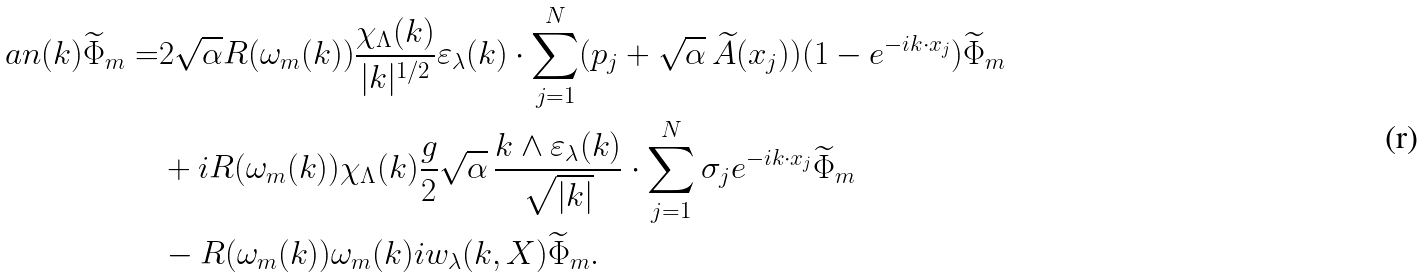<formula> <loc_0><loc_0><loc_500><loc_500>\ a n ( k ) \widetilde { \Phi } _ { m } = & 2 \sqrt { \alpha } R ( \omega _ { m } ( k ) ) \frac { \chi _ { \Lambda } ( k ) } { | k | ^ { 1 / 2 } } \varepsilon _ { \lambda } ( k ) \cdot \sum _ { j = 1 } ^ { N } ( p _ { j } + \sqrt { \alpha } \, \widetilde { A } ( x _ { j } ) ) ( 1 - e ^ { - i k \cdot x _ { j } } ) \widetilde { \Phi } _ { m } \\ & + i R ( \omega _ { m } ( k ) ) { \chi _ { \Lambda } ( k ) } \frac { g } { 2 } \sqrt { \alpha } \, \frac { k \wedge \varepsilon _ { \lambda } ( k ) } { \sqrt { | k | } } \cdot \sum _ { j = 1 } ^ { N } \sigma _ { j } e ^ { - i k \cdot x _ { j } } \widetilde { \Phi } _ { m } \\ & - R ( \omega _ { m } ( k ) ) \omega _ { m } ( k ) i w _ { \lambda } ( k , X ) \widetilde { \Phi } _ { m } .</formula> 